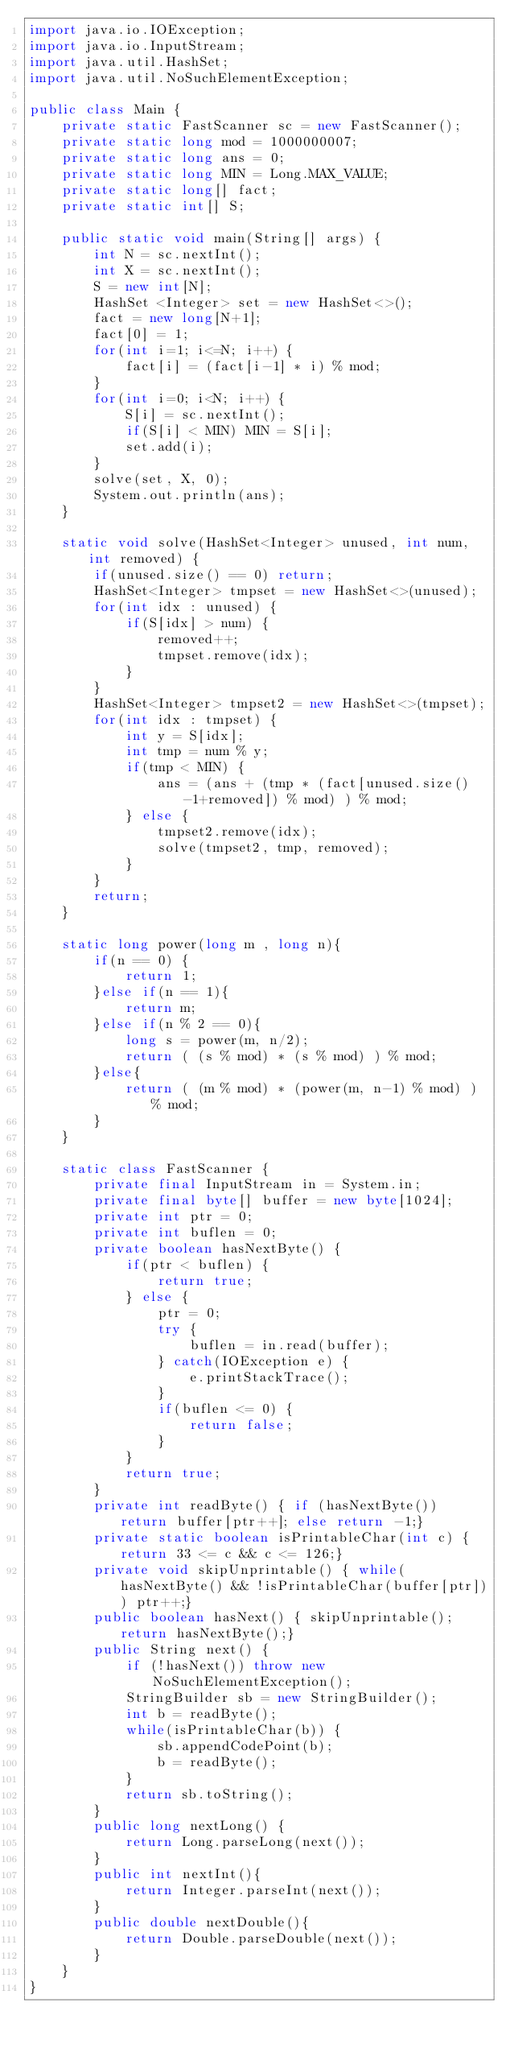Convert code to text. <code><loc_0><loc_0><loc_500><loc_500><_Java_>import java.io.IOException;
import java.io.InputStream;
import java.util.HashSet;
import java.util.NoSuchElementException;

public class Main {
    private static FastScanner sc = new FastScanner();
    private static long mod = 1000000007;
    private static long ans = 0;
    private static long MIN = Long.MAX_VALUE;
    private static long[] fact;
    private static int[] S;

    public static void main(String[] args) {
    	int N = sc.nextInt();
    	int X = sc.nextInt();
    	S = new int[N];
    	HashSet <Integer> set = new HashSet<>();
    	fact = new long[N+1];
    	fact[0] = 1;
    	for(int i=1; i<=N; i++) {
    		fact[i] = (fact[i-1] * i) % mod;
    	}
    	for(int i=0; i<N; i++) {
    		S[i] = sc.nextInt();
    		if(S[i] < MIN) MIN = S[i];
    		set.add(i);
    	}
    	solve(set, X, 0);
    	System.out.println(ans);
    }

    static void solve(HashSet<Integer> unused, int num, int removed) {
    	if(unused.size() == 0) return;
		HashSet<Integer> tmpset = new HashSet<>(unused);
		for(int idx : unused) {
			if(S[idx] > num) {
				removed++;
				tmpset.remove(idx);
			}
		}
		HashSet<Integer> tmpset2 = new HashSet<>(tmpset);
    	for(int idx : tmpset) {
    		int y = S[idx];
    		int tmp = num % y;
    		if(tmp < MIN) {
    			ans = (ans + (tmp * (fact[unused.size()-1+removed]) % mod) ) % mod;
    		} else {
    			tmpset2.remove(idx);
    			solve(tmpset2, tmp, removed);
    		}
    	}
    	return;
    }

    static long power(long m , long n){
    	if(n == 0) {
    		return 1;
    	}else if(n == 1){
            return m;
        }else if(n % 2 == 0){
            long s = power(m, n/2);
            return ( (s % mod) * (s % mod) ) % mod;
        }else{
            return ( (m % mod) * (power(m, n-1) % mod) ) % mod;
        }
    }

    static class FastScanner {
        private final InputStream in = System.in;
        private final byte[] buffer = new byte[1024];
        private int ptr = 0;
        private int buflen = 0;
        private boolean hasNextByte() {
            if(ptr < buflen) {
                return true;
            } else {
                ptr = 0;
                try {
                    buflen = in.read(buffer);
                } catch(IOException e) {
                    e.printStackTrace();
                }
                if(buflen <= 0) {
                    return false;
                }
            }
            return true;
        }
        private int readByte() { if (hasNextByte()) return buffer[ptr++]; else return -1;}
        private static boolean isPrintableChar(int c) { return 33 <= c && c <= 126;}
        private void skipUnprintable() { while(hasNextByte() && !isPrintableChar(buffer[ptr])) ptr++;}
        public boolean hasNext() { skipUnprintable(); return hasNextByte();}
        public String next() {
            if (!hasNext()) throw new NoSuchElementException();
            StringBuilder sb = new StringBuilder();
            int b = readByte();
            while(isPrintableChar(b)) {
                sb.appendCodePoint(b);
                b = readByte();
            }
            return sb.toString();
        }
        public long nextLong() {
            return Long.parseLong(next());
        }
        public int nextInt(){
            return Integer.parseInt(next());
        }
        public double nextDouble(){
            return Double.parseDouble(next());
        }
    }
}
</code> 